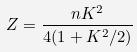Convert formula to latex. <formula><loc_0><loc_0><loc_500><loc_500>Z = \frac { n K ^ { 2 } } { 4 ( 1 + K ^ { 2 } / 2 ) }</formula> 